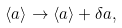Convert formula to latex. <formula><loc_0><loc_0><loc_500><loc_500>\langle a \rangle \rightarrow \langle a \rangle + \delta a ,</formula> 